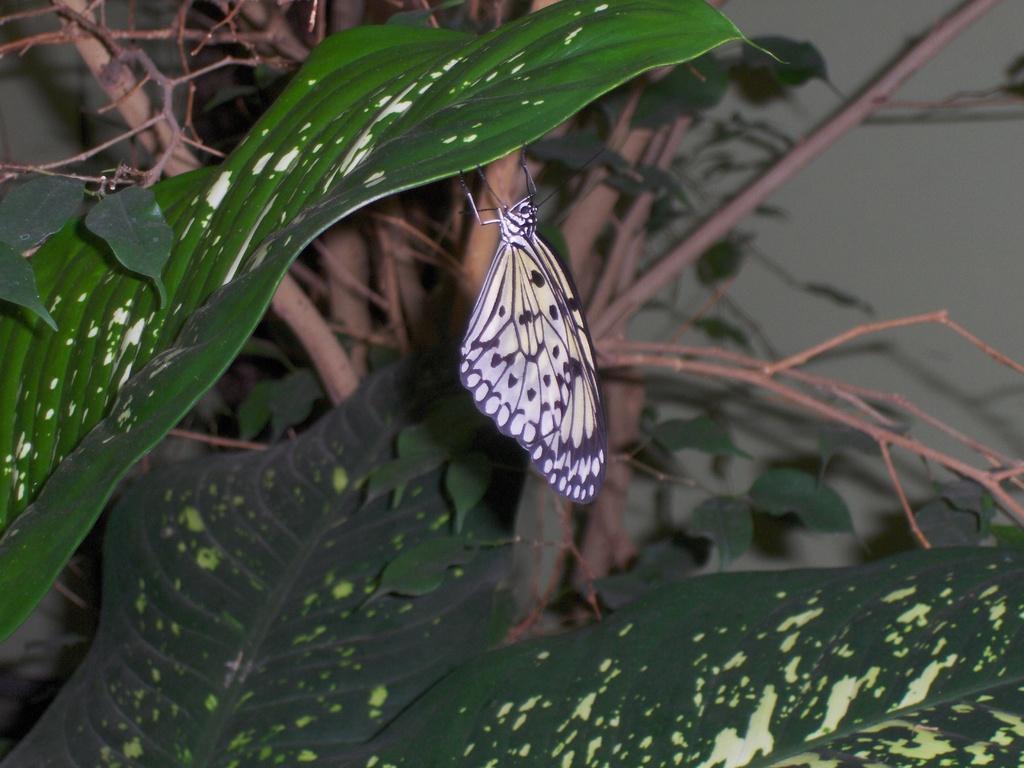How would you summarize this image in a sentence or two? In this image I can see a beautiful yellow and black color butterfly is holding the leaf of a tree. 